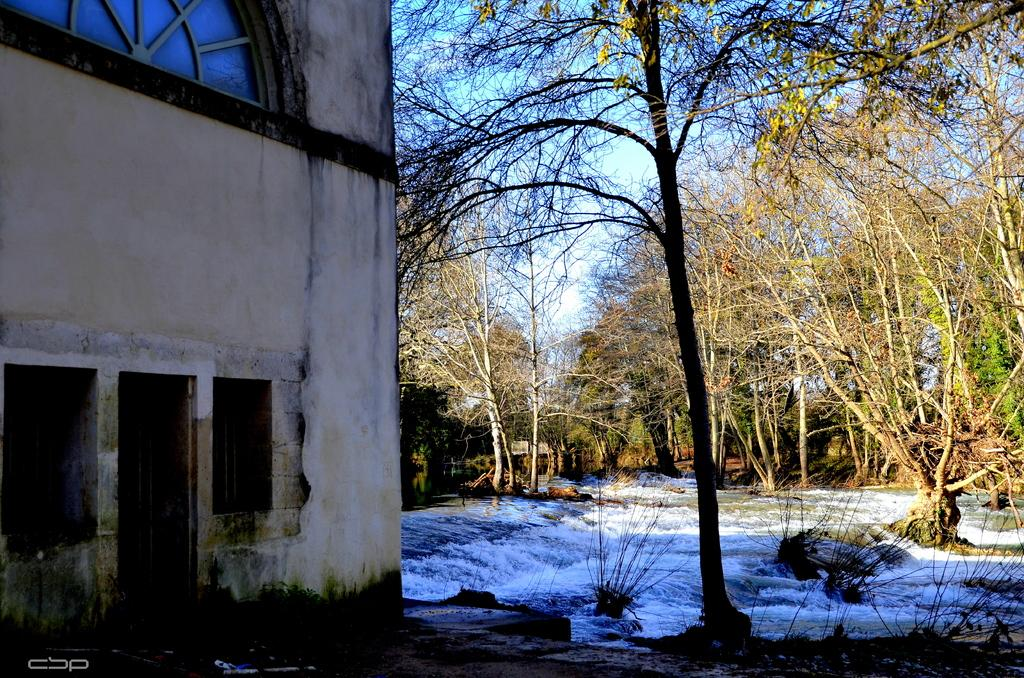What is the primary natural element in the image? There is running water in the image. What type of geological features are present in the image? There are rocks in the image. What type of vegetation is present in the image? There are trees in the image. What type of man-made structure is present in the image? There is a building in the image. What is visible in the sky in the image? The sky is visible in the image with clouds. How many cows are grazing near the building in the image? There are no cows present in the image. What type of power source is visible in the image? There is no power source visible in the image. 